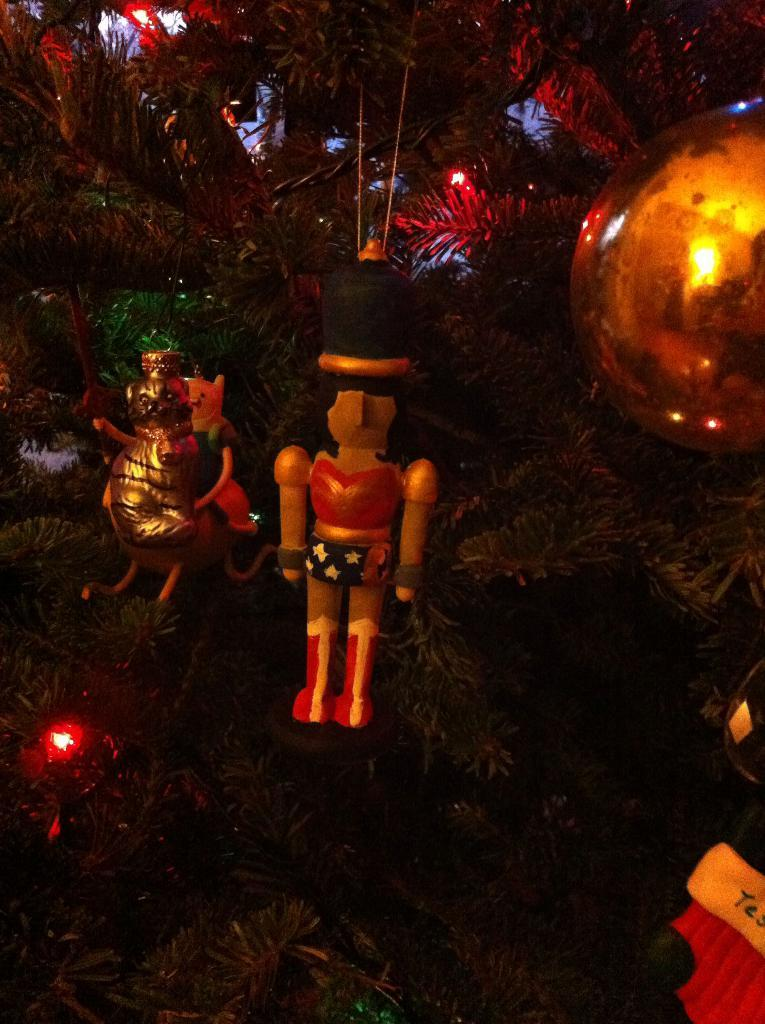What type of tree is in the image? There is a Christmas tree in the image. What can be seen in addition to the Christmas tree? There are decorative objects in the image. What type of hobbies can be seen being practiced by the clam in the image? There is no clam present in the image, and therefore no hobbies can be observed. 